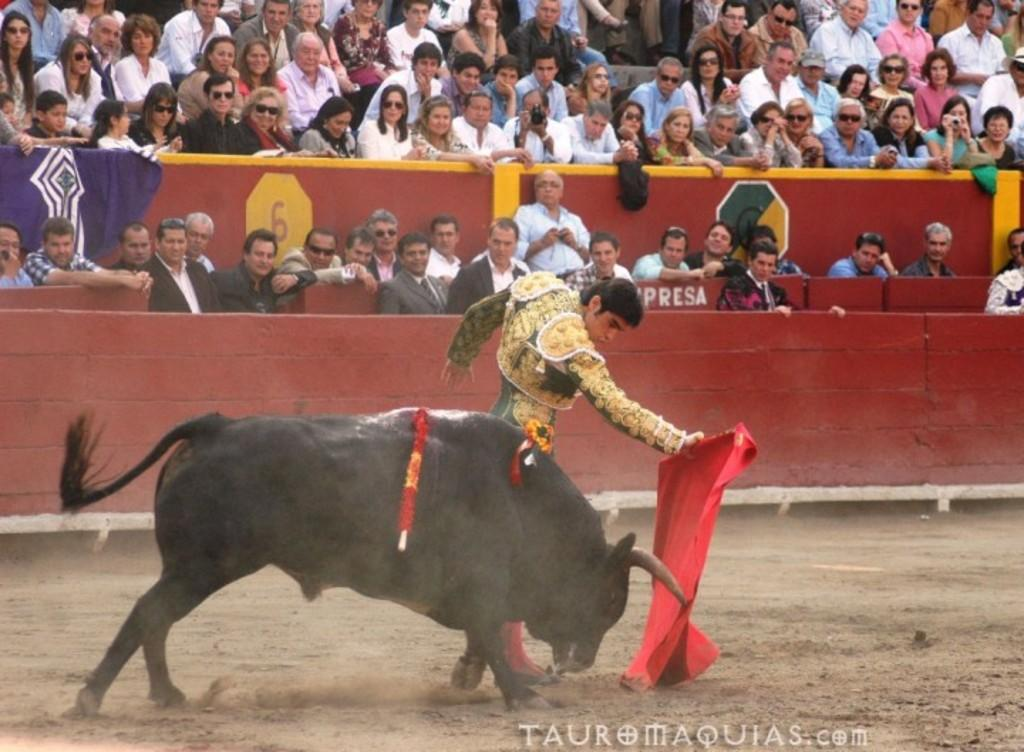What is the main subject in the foreground of the image? There is an animal in the foreground of the image. What is the person in the foreground holding? The person is holding a red cloth in the foreground. What can be seen in the background of the image? There are many people sitting in the background of the image. What type of lawyer is present in the image? There is no lawyer present in the image. How many people are being pushed in the image? There is no pushing activity depicted in the image. 